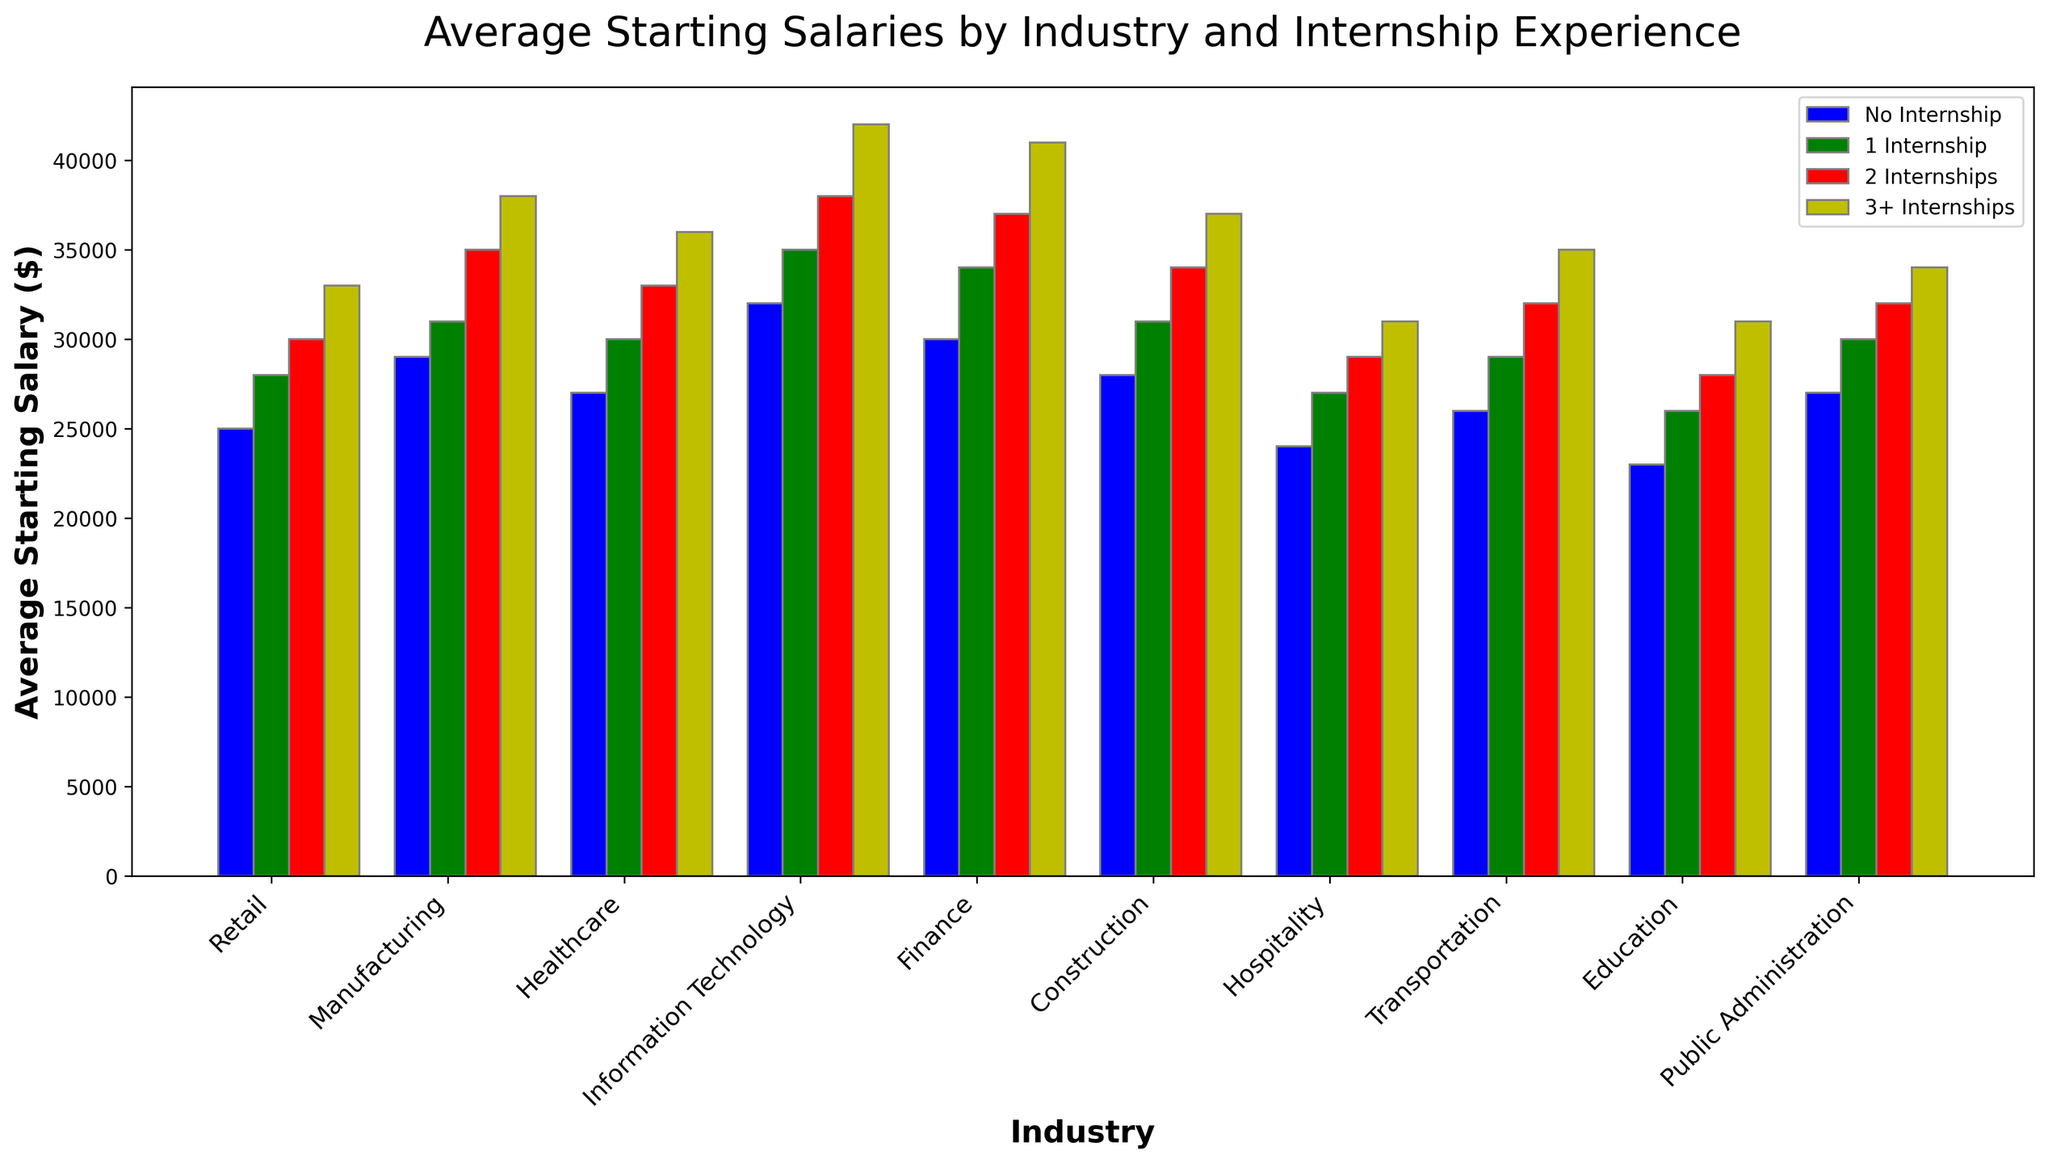Which industry shows the highest average starting salary for high school graduates with 2 internships? Look at the red bars representing "2 Internships" and identify the tallest one.
Answer: Information Technology What is the difference in average starting salary between no internship and 3+ internships in the Retail industry? Compare the height of the blue bar ("No Internship") and the yellow bar ("3+ Internships") for Retail.
Answer: $8,000 In which industry does having 3+ internships lead to the highest increase in starting salary compared to having no internship? Calculate the difference in salary between the "No Internship" and "3+ Internships" colored bars for each industry and identify the largest increase.
Answer: Information Technology Which industry has the smallest difference in average starting salaries between 1 internship and 3+ internships? Look at the green ("1 Internship") and yellow ("3+ Internships") bars for each industry and compare the differences to find the smallest gap.
Answer: Public Administration Rank the industries from highest to lowest average starting salary for graduates with no internship. Identify the height of the blue bars for each industry and order them from tallest to shortest.
Answer: Information Technology > Finance > Manufacturing > Healthcare > Construction > Transportation > Public Administration > Retail > Hospitality > Education What is the average increase in starting salary for each additional internship in the Healthcare industry? Calculate the difference between consecutive bars for Healthcare. (1 Internship: 30,000-27,000; 2 Internships: 33,000-30,000; 3+ Internships: 36,000-33,000), then find the average of these differences.
Answer: $3,000 How does the starting salary for graduates with 2 internships in Manufacturing compare to those in Finance? Compare the heights of the red bars representing "2 Internships" in Manufacturing and Finance.
Answer: Manufacturing is $2,000 lower than Finance Which industry shows the least variation in starting salaries across different levels of internship experience? Identify the industry where the range (difference between highest and lowest salary) of the bars is smallest.
Answer: Public Administration 